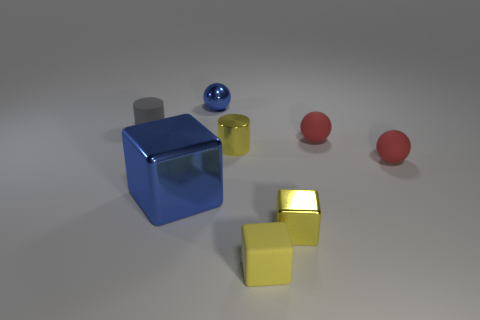Add 1 yellow things. How many objects exist? 9 Subtract all blocks. How many objects are left? 5 Subtract 0 red cubes. How many objects are left? 8 Subtract all gray matte objects. Subtract all red rubber balls. How many objects are left? 5 Add 3 gray matte objects. How many gray matte objects are left? 4 Add 5 gray rubber objects. How many gray rubber objects exist? 6 